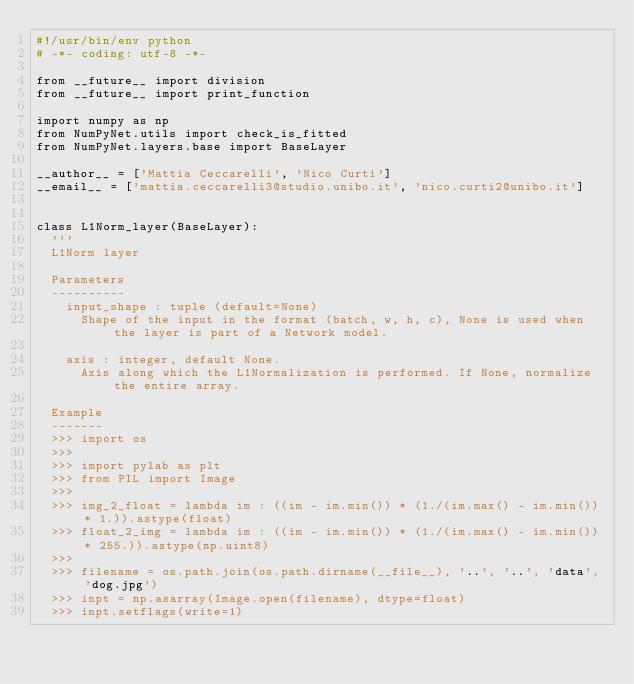Convert code to text. <code><loc_0><loc_0><loc_500><loc_500><_Python_>#!/usr/bin/env python
# -*- coding: utf-8 -*-

from __future__ import division
from __future__ import print_function

import numpy as np
from NumPyNet.utils import check_is_fitted
from NumPyNet.layers.base import BaseLayer

__author__ = ['Mattia Ceccarelli', 'Nico Curti']
__email__ = ['mattia.ceccarelli3@studio.unibo.it', 'nico.curti2@unibo.it']


class L1Norm_layer(BaseLayer):
  '''
  L1Norm layer

  Parameters
  ----------
    input_shape : tuple (default=None)
      Shape of the input in the format (batch, w, h, c), None is used when the layer is part of a Network model.

    axis : integer, default None.
      Axis along which the L1Normalization is performed. If None, normalize the entire array.

  Example
  -------
  >>> import os
  >>>
  >>> import pylab as plt
  >>> from PIL import Image
  >>>
  >>> img_2_float = lambda im : ((im - im.min()) * (1./(im.max() - im.min()) * 1.)).astype(float)
  >>> float_2_img = lambda im : ((im - im.min()) * (1./(im.max() - im.min()) * 255.)).astype(np.uint8)
  >>>
  >>> filename = os.path.join(os.path.dirname(__file__), '..', '..', 'data', 'dog.jpg')
  >>> inpt = np.asarray(Image.open(filename), dtype=float)
  >>> inpt.setflags(write=1)</code> 